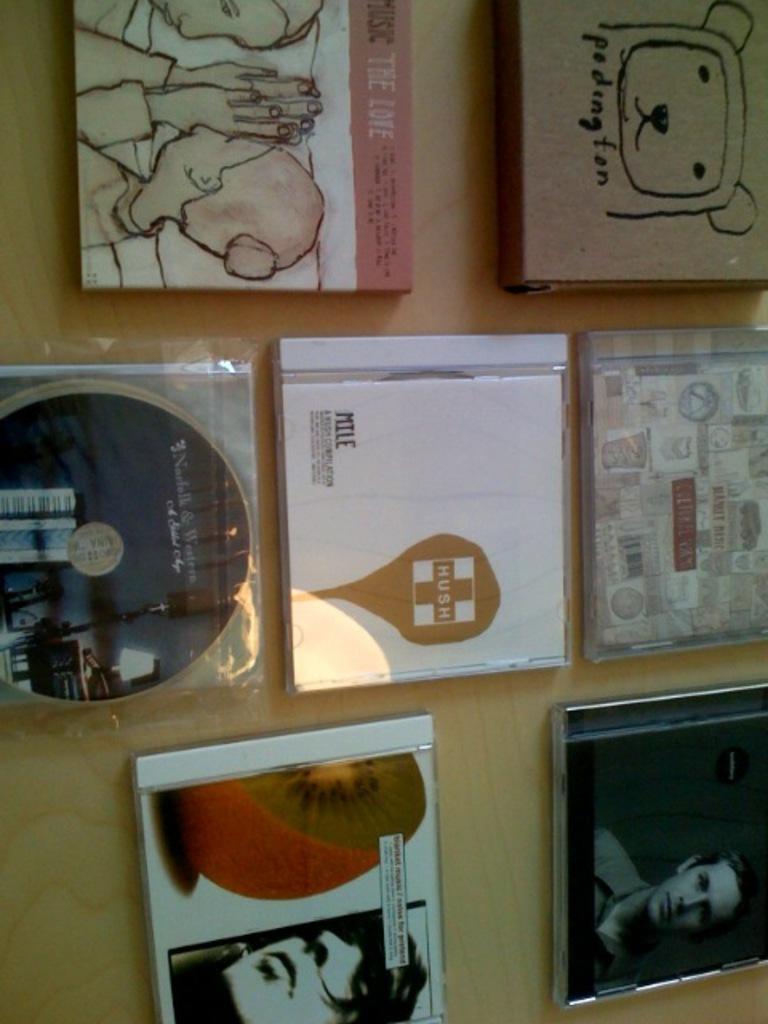In one or two sentences, can you explain what this image depicts? We can see CD's and boxes on the wooden surface. 